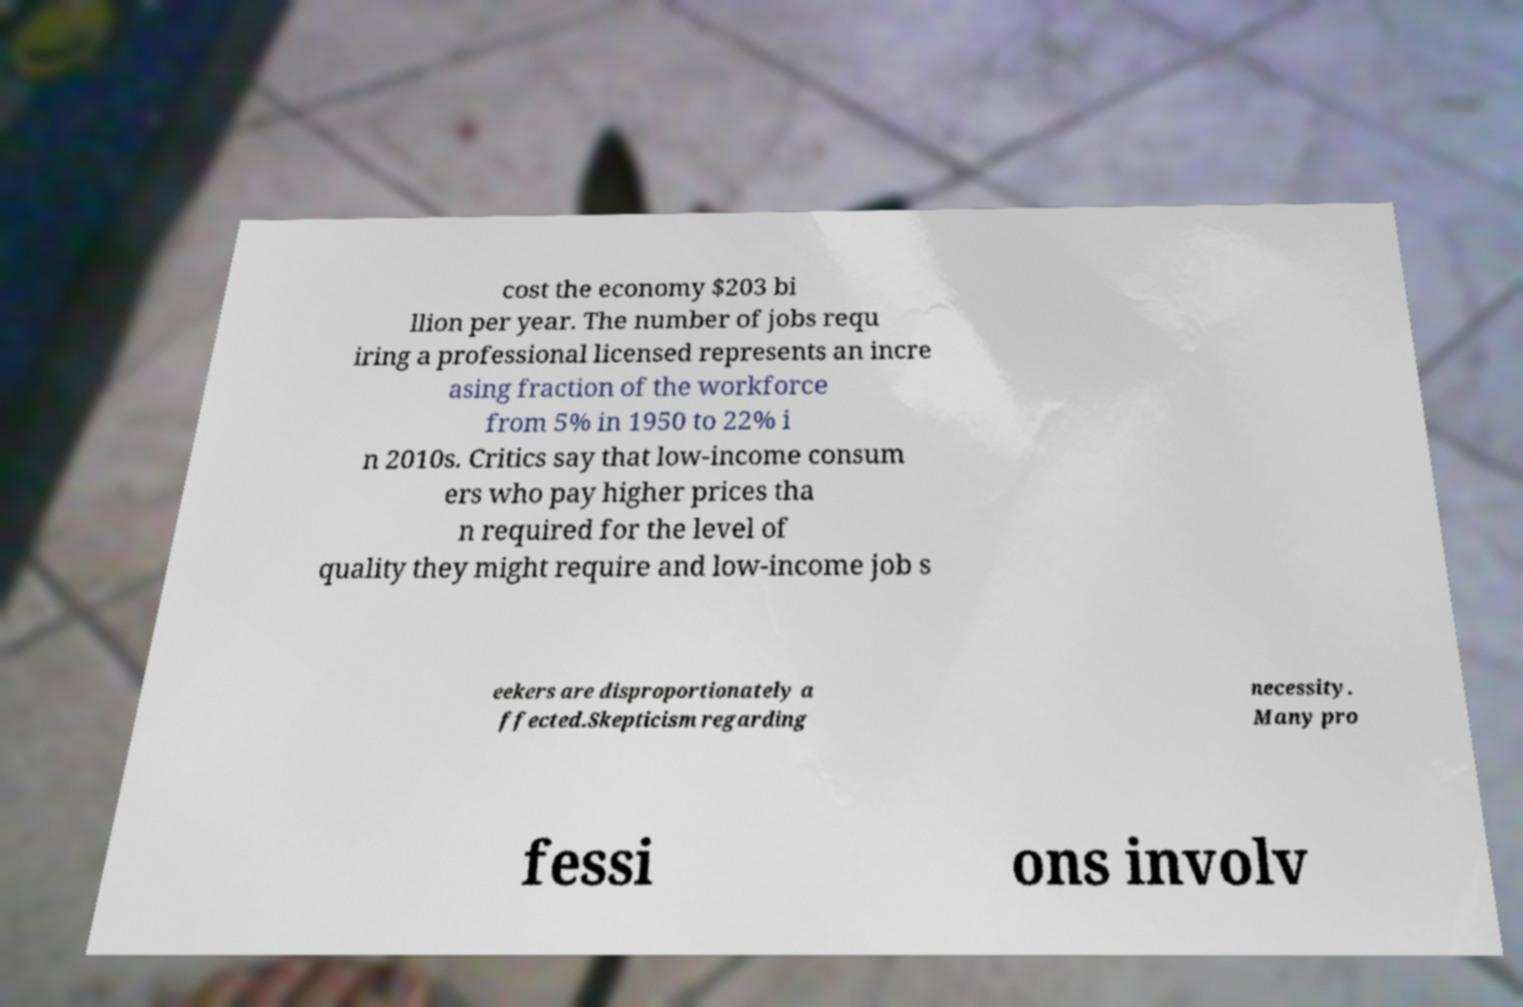Could you assist in decoding the text presented in this image and type it out clearly? cost the economy $203 bi llion per year. The number of jobs requ iring a professional licensed represents an incre asing fraction of the workforce from 5% in 1950 to 22% i n 2010s. Critics say that low-income consum ers who pay higher prices tha n required for the level of quality they might require and low-income job s eekers are disproportionately a ffected.Skepticism regarding necessity. Many pro fessi ons involv 